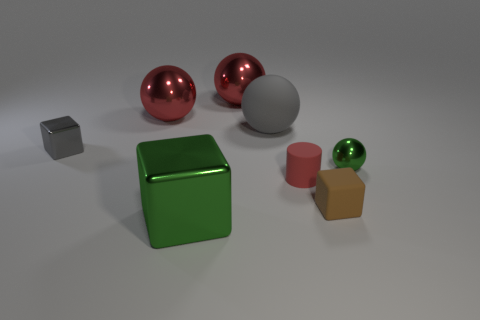How many other objects are the same material as the tiny red cylinder?
Your answer should be compact. 2. Are the green object that is in front of the tiny matte cube and the cube to the right of the small red cylinder made of the same material?
Your answer should be compact. No. Is there any other thing that is the same shape as the tiny gray metallic thing?
Give a very brief answer. Yes. Do the tiny gray object and the small cube that is right of the large matte thing have the same material?
Ensure brevity in your answer.  No. The sphere that is to the right of the gray object on the right side of the small block left of the big green shiny object is what color?
Offer a terse response. Green. What is the shape of the green thing that is the same size as the gray ball?
Provide a succinct answer. Cube. There is a metal object in front of the tiny sphere; is it the same size as the rubber object that is behind the small gray block?
Give a very brief answer. Yes. There is a red object that is in front of the big gray rubber object; what is its size?
Give a very brief answer. Small. There is a ball that is the same color as the tiny metal cube; what is its material?
Your answer should be very brief. Rubber. The metal ball that is the same size as the red cylinder is what color?
Provide a short and direct response. Green. 